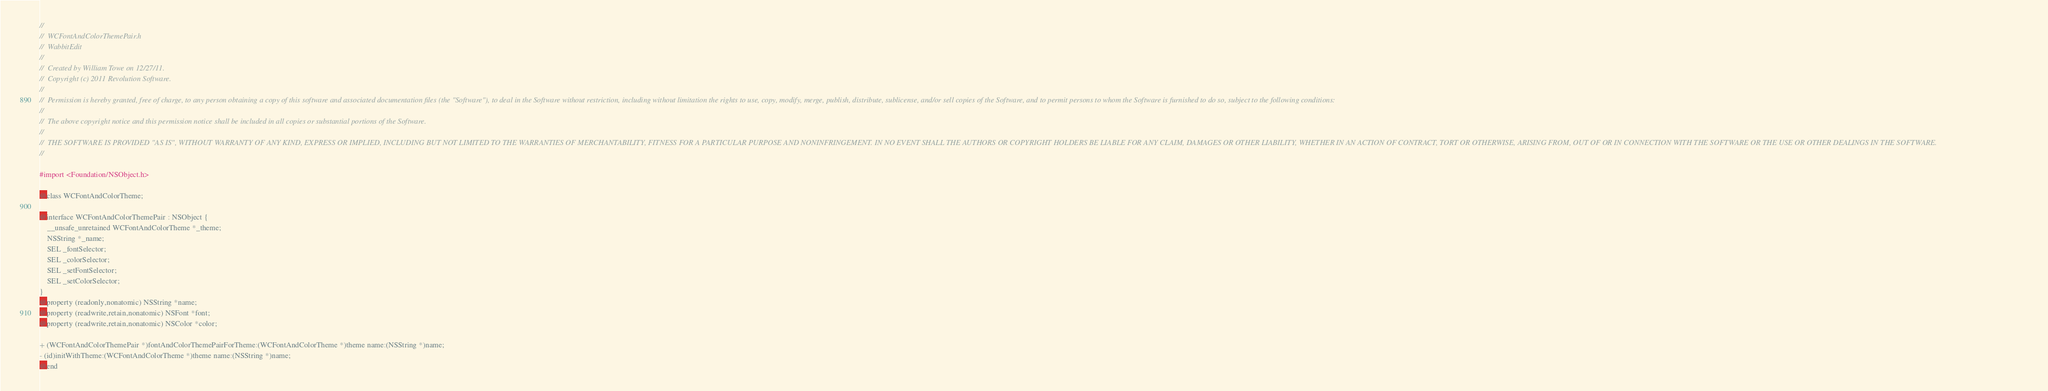Convert code to text. <code><loc_0><loc_0><loc_500><loc_500><_C_>//
//  WCFontAndColorThemePair.h
//  WabbitEdit
//
//  Created by William Towe on 12/27/11.
//  Copyright (c) 2011 Revolution Software.
//
//  Permission is hereby granted, free of charge, to any person obtaining a copy of this software and associated documentation files (the "Software"), to deal in the Software without restriction, including without limitation the rights to use, copy, modify, merge, publish, distribute, sublicense, and/or sell copies of the Software, and to permit persons to whom the Software is furnished to do so, subject to the following conditions:
// 
//  The above copyright notice and this permission notice shall be included in all copies or substantial portions of the Software.
// 
//  THE SOFTWARE IS PROVIDED "AS IS", WITHOUT WARRANTY OF ANY KIND, EXPRESS OR IMPLIED, INCLUDING BUT NOT LIMITED TO THE WARRANTIES OF MERCHANTABILITY, FITNESS FOR A PARTICULAR PURPOSE AND NONINFRINGEMENT. IN NO EVENT SHALL THE AUTHORS OR COPYRIGHT HOLDERS BE LIABLE FOR ANY CLAIM, DAMAGES OR OTHER LIABILITY, WHETHER IN AN ACTION OF CONTRACT, TORT OR OTHERWISE, ARISING FROM, OUT OF OR IN CONNECTION WITH THE SOFTWARE OR THE USE OR OTHER DEALINGS IN THE SOFTWARE.
//

#import <Foundation/NSObject.h>

@class WCFontAndColorTheme;

@interface WCFontAndColorThemePair : NSObject {
	__unsafe_unretained WCFontAndColorTheme *_theme;
	NSString *_name;
	SEL _fontSelector;
	SEL _colorSelector;
	SEL _setFontSelector;
	SEL _setColorSelector;
}
@property (readonly,nonatomic) NSString *name;
@property (readwrite,retain,nonatomic) NSFont *font;
@property (readwrite,retain,nonatomic) NSColor *color;

+ (WCFontAndColorThemePair *)fontAndColorThemePairForTheme:(WCFontAndColorTheme *)theme name:(NSString *)name;
- (id)initWithTheme:(WCFontAndColorTheme *)theme name:(NSString *)name;
@end
</code> 